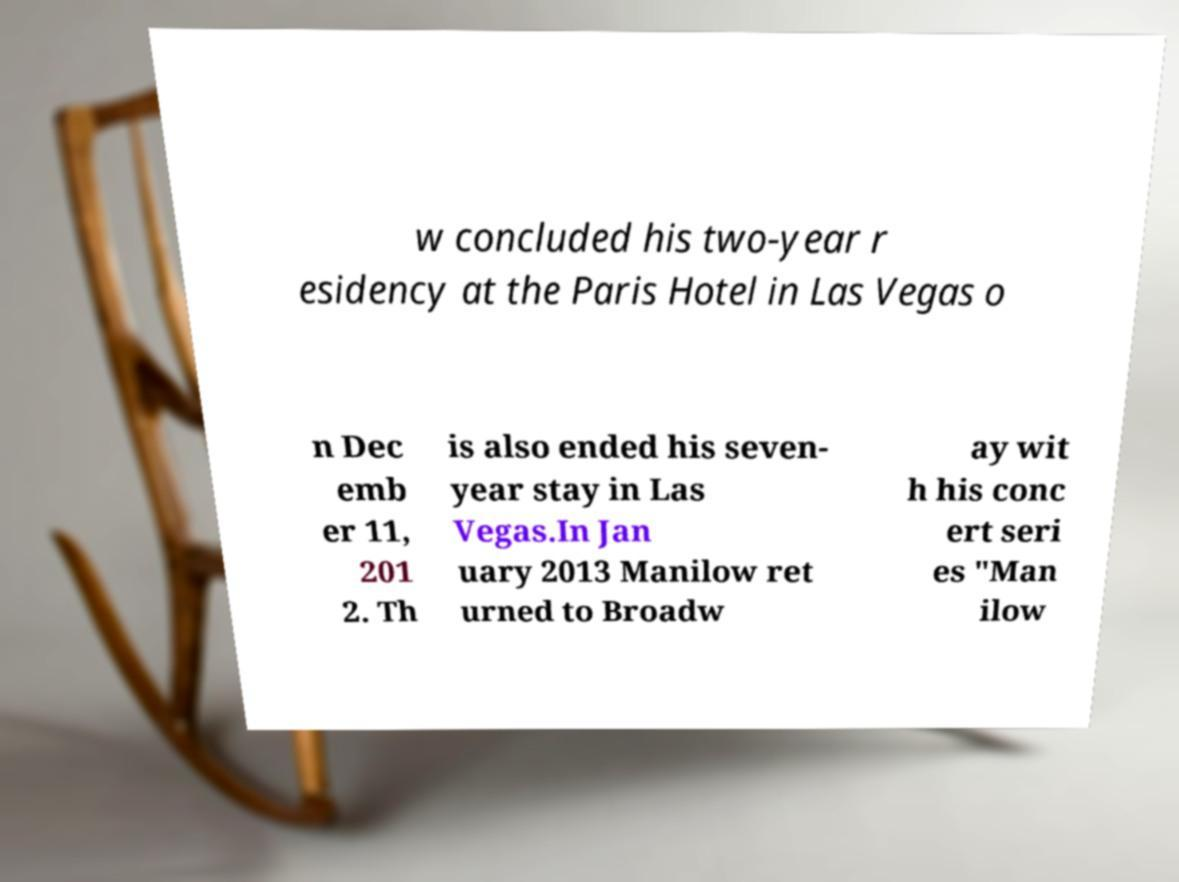What messages or text are displayed in this image? I need them in a readable, typed format. w concluded his two-year r esidency at the Paris Hotel in Las Vegas o n Dec emb er 11, 201 2. Th is also ended his seven- year stay in Las Vegas.In Jan uary 2013 Manilow ret urned to Broadw ay wit h his conc ert seri es "Man ilow 